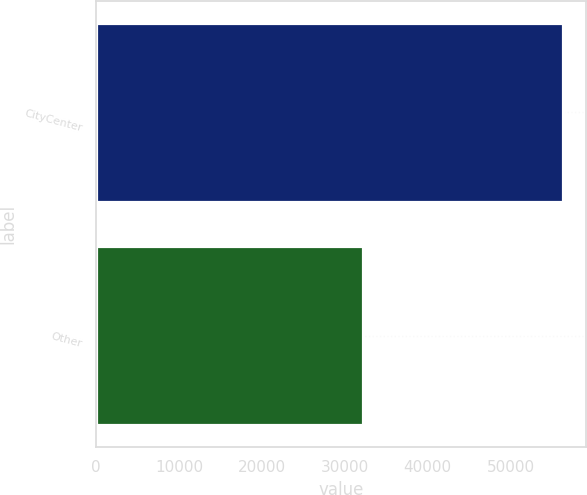Convert chart. <chart><loc_0><loc_0><loc_500><loc_500><bar_chart><fcel>CityCenter<fcel>Other<nl><fcel>56291<fcel>32166<nl></chart> 